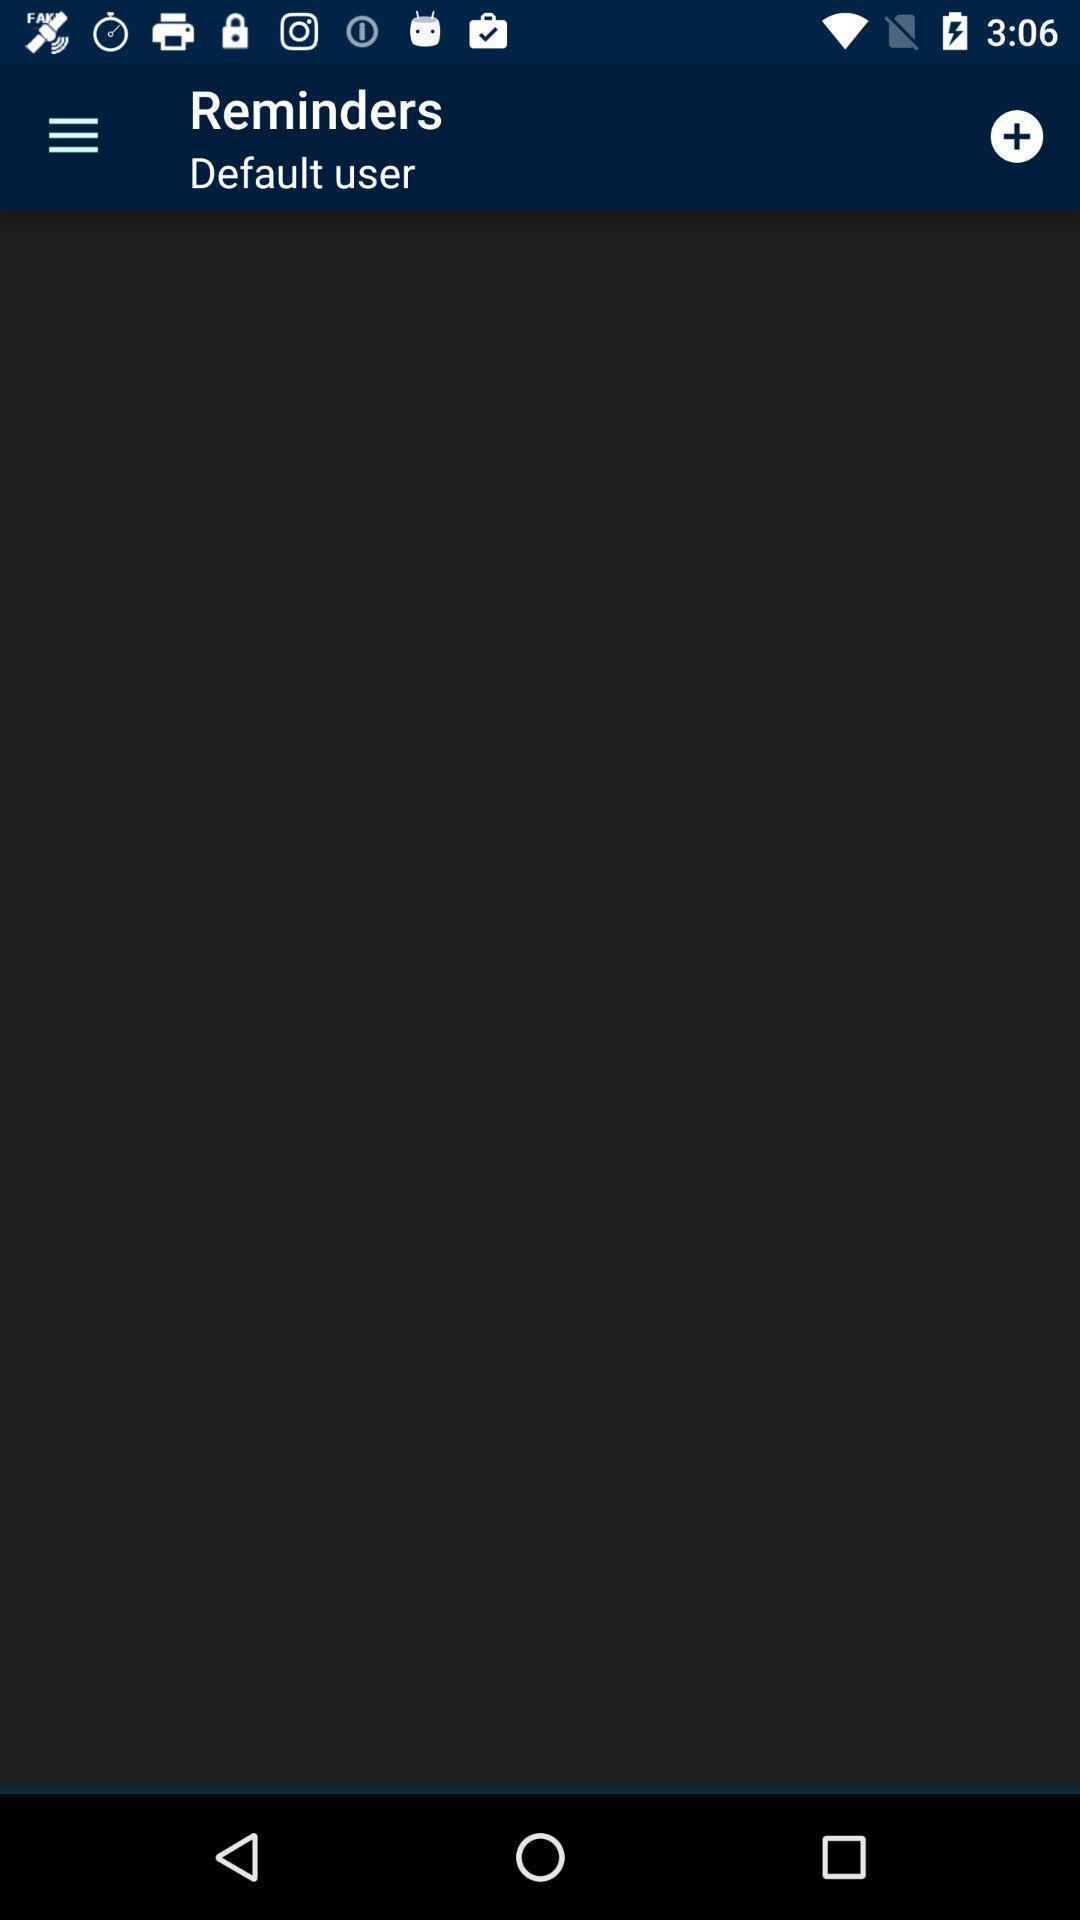Provide a detailed account of this screenshot. Reminders page. 